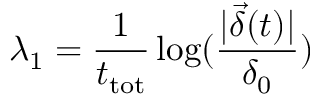<formula> <loc_0><loc_0><loc_500><loc_500>\lambda _ { 1 } = \frac { 1 } { t _ { t o t } } \log ( \frac { | \vec { \delta } ( t ) | } { \delta _ { 0 } } )</formula> 